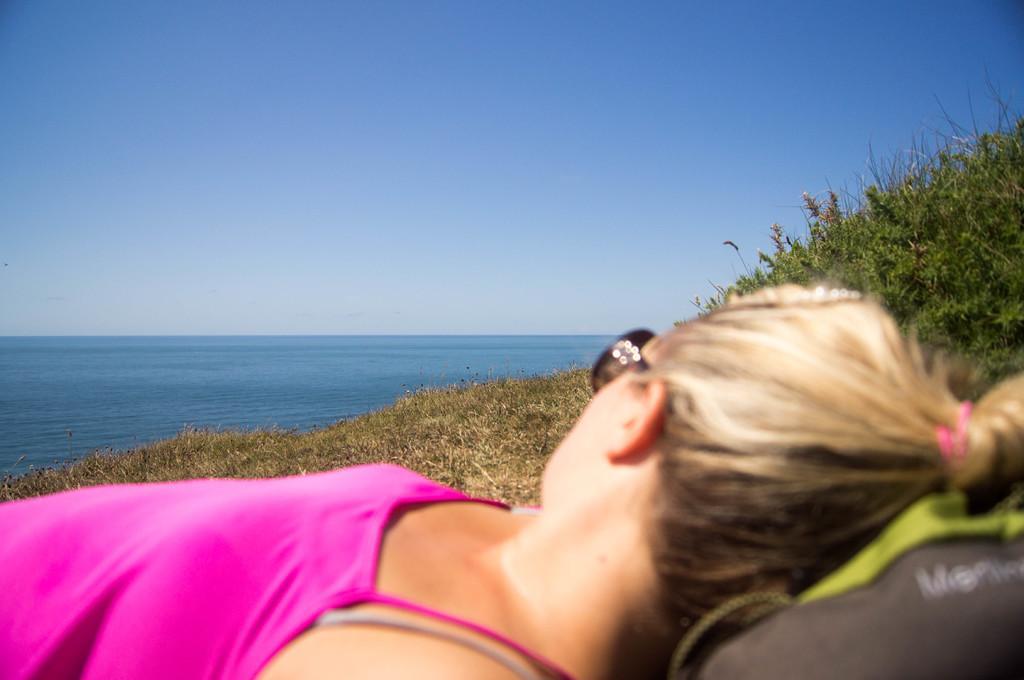Could you give a brief overview of what you see in this image? In this image there is a lady lying on a grassland, in the background there is the sea and the sky. 